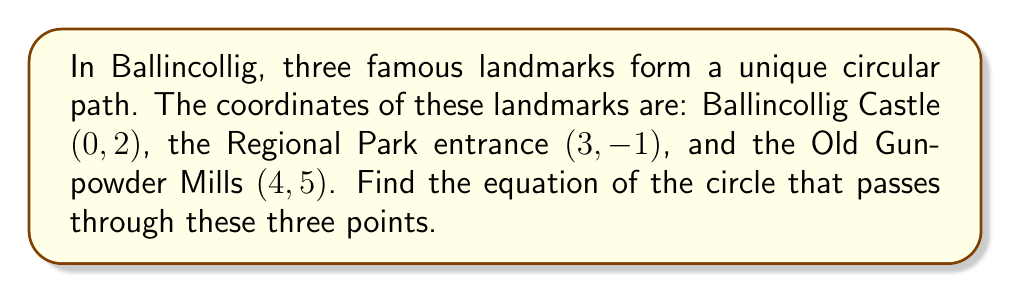Provide a solution to this math problem. To find the equation of a circle passing through three points, we can use the general equation of a circle: $(x-h)^2 + (y-k)^2 = r^2$, where $(h,k)$ is the center and $r$ is the radius.

Step 1: Let's use the general form $x^2 + y^2 + Dx + Ey + F = 0$.

Step 2: Substitute the coordinates of the three points into this equation:

(0, 2): $0^2 + 2^2 + 0D + 2E + F = 0$
(3, -1): $3^2 + (-1)^2 + 3D + (-1)E + F = 0$
(4, 5): $4^2 + 5^2 + 4D + 5E + F = 0$

Step 3: Simplify these equations:

$4 + 2E + F = 0$ ... (1)
$10 + 3D - E + F = 0$ ... (2)
$41 + 4D + 5E + F = 0$ ... (3)

Step 4: Subtract equation (1) from (2) and (3):

$6 + 3D - 3E = 0$ ... (4)
$37 + 4D + 3E = 0$ ... (5)

Step 5: Multiply equation (4) by 4 and equation (5) by 3:

$24 + 12D - 12E = 0$ ... (6)
$111 + 12D + 9E = 0$ ... (7)

Step 6: Subtract equation (6) from (7):

$87 + 21E = 0$
$E = -\frac{87}{21} = -\frac{29}{7}$

Step 7: Substitute this value of $E$ into equation (4):

$6 + 3D + 3(\frac{29}{7}) = 0$
$3D = -6 - \frac{87}{7} = -\frac{129}{7}$
$D = -\frac{43}{7}$

Step 8: Substitute $D$ and $E$ into equation (1):

$4 + 2(-\frac{29}{7}) + F = 0$
$F = -4 + \frac{58}{7} = \frac{30}{7}$

Step 9: The equation of the circle is:

$x^2 + y^2 - \frac{43}{7}x - \frac{29}{7}y + \frac{30}{7} = 0$

Step 10: To get the standard form, complete the square for both $x$ and $y$ terms:

$(x^2 - \frac{43}{7}x + (\frac{43}{14})^2) + (y^2 - \frac{29}{7}y + (\frac{29}{14})^2) = (\frac{43}{14})^2 + (\frac{29}{14})^2 - \frac{30}{7}$

$(x - \frac{43}{14})^2 + (y - \frac{29}{14})^2 = \frac{2401}{196}$
Answer: The equation of the circle passing through the three landmarks in Ballincollig is:

$$(x - \frac{43}{14})^2 + (y - \frac{29}{14})^2 = \frac{2401}{196}$$

Where the center is $(\frac{43}{14}, \frac{29}{14})$ and the radius is $\frac{49}{14}$. 